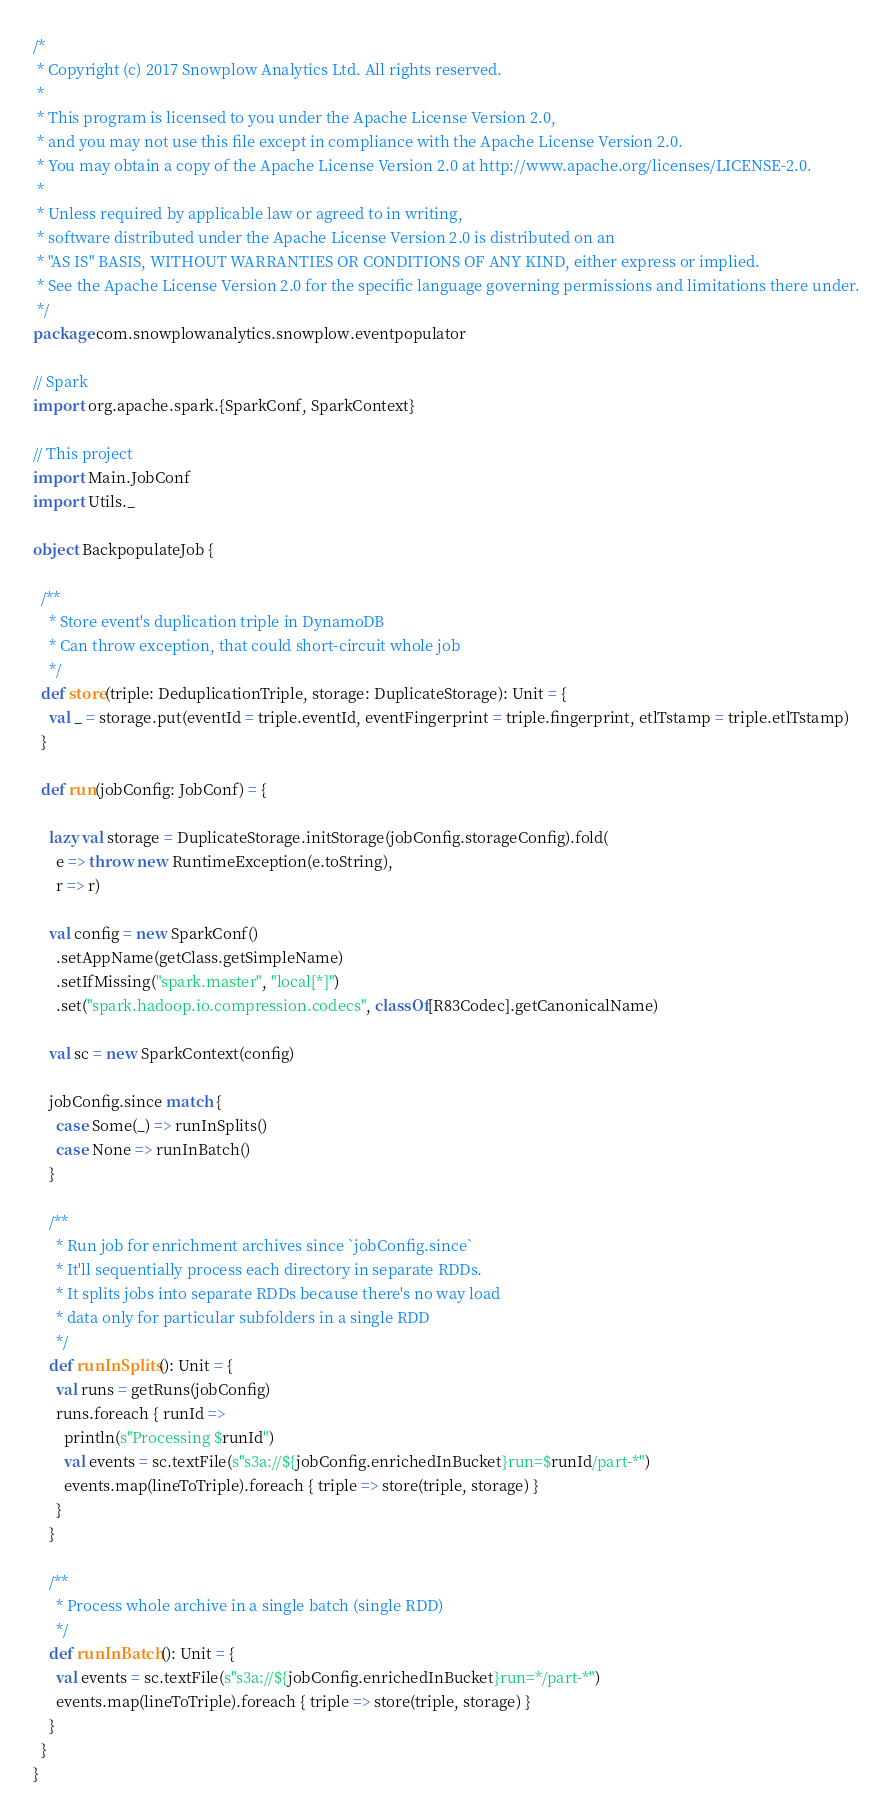<code> <loc_0><loc_0><loc_500><loc_500><_Scala_>/*
 * Copyright (c) 2017 Snowplow Analytics Ltd. All rights reserved.
 *
 * This program is licensed to you under the Apache License Version 2.0,
 * and you may not use this file except in compliance with the Apache License Version 2.0.
 * You may obtain a copy of the Apache License Version 2.0 at http://www.apache.org/licenses/LICENSE-2.0.
 *
 * Unless required by applicable law or agreed to in writing,
 * software distributed under the Apache License Version 2.0 is distributed on an
 * "AS IS" BASIS, WITHOUT WARRANTIES OR CONDITIONS OF ANY KIND, either express or implied.
 * See the Apache License Version 2.0 for the specific language governing permissions and limitations there under.
 */
package com.snowplowanalytics.snowplow.eventpopulator

// Spark
import org.apache.spark.{SparkConf, SparkContext}

// This project
import Main.JobConf
import Utils._

object BackpopulateJob {

  /**
    * Store event's duplication triple in DynamoDB
    * Can throw exception, that could short-circuit whole job
    */
  def store(triple: DeduplicationTriple, storage: DuplicateStorage): Unit = {
    val _ = storage.put(eventId = triple.eventId, eventFingerprint = triple.fingerprint, etlTstamp = triple.etlTstamp)
  }

  def run(jobConfig: JobConf) = {

    lazy val storage = DuplicateStorage.initStorage(jobConfig.storageConfig).fold(
      e => throw new RuntimeException(e.toString),
      r => r)

    val config = new SparkConf()
      .setAppName(getClass.getSimpleName)
      .setIfMissing("spark.master", "local[*]")
      .set("spark.hadoop.io.compression.codecs", classOf[R83Codec].getCanonicalName)

    val sc = new SparkContext(config)

    jobConfig.since match {
      case Some(_) => runInSplits()
      case None => runInBatch()
    }

    /**
      * Run job for enrichment archives since `jobConfig.since`
      * It'll sequentially process each directory in separate RDDs.
      * It splits jobs into separate RDDs because there's no way load
      * data only for particular subfolders in a single RDD
      */
    def runInSplits(): Unit = {
      val runs = getRuns(jobConfig)
      runs.foreach { runId =>
        println(s"Processing $runId")
        val events = sc.textFile(s"s3a://${jobConfig.enrichedInBucket}run=$runId/part-*")
        events.map(lineToTriple).foreach { triple => store(triple, storage) }
      }
    }

    /**
      * Process whole archive in a single batch (single RDD)
      */
    def runInBatch(): Unit = {
      val events = sc.textFile(s"s3a://${jobConfig.enrichedInBucket}run=*/part-*")
      events.map(lineToTriple).foreach { triple => store(triple, storage) }
    }
  }
}
</code> 